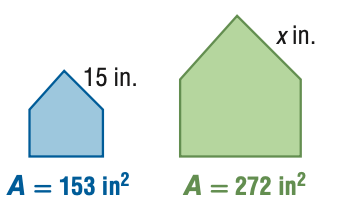Question: For the pair of similar figures, use the given areas to find the scale factor from the blue to the green figure.
Choices:
A. \frac { 9 } { 16 }
B. \frac { 3 } { 4 }
C. \frac { 4 } { 3 }
D. \frac { 16 } { 9 }
Answer with the letter. Answer: B Question: For the pair of similar figures, use the given areas to find x.
Choices:
A. 8.4
B. 11.3
C. 20.0
D. 26.7
Answer with the letter. Answer: C 